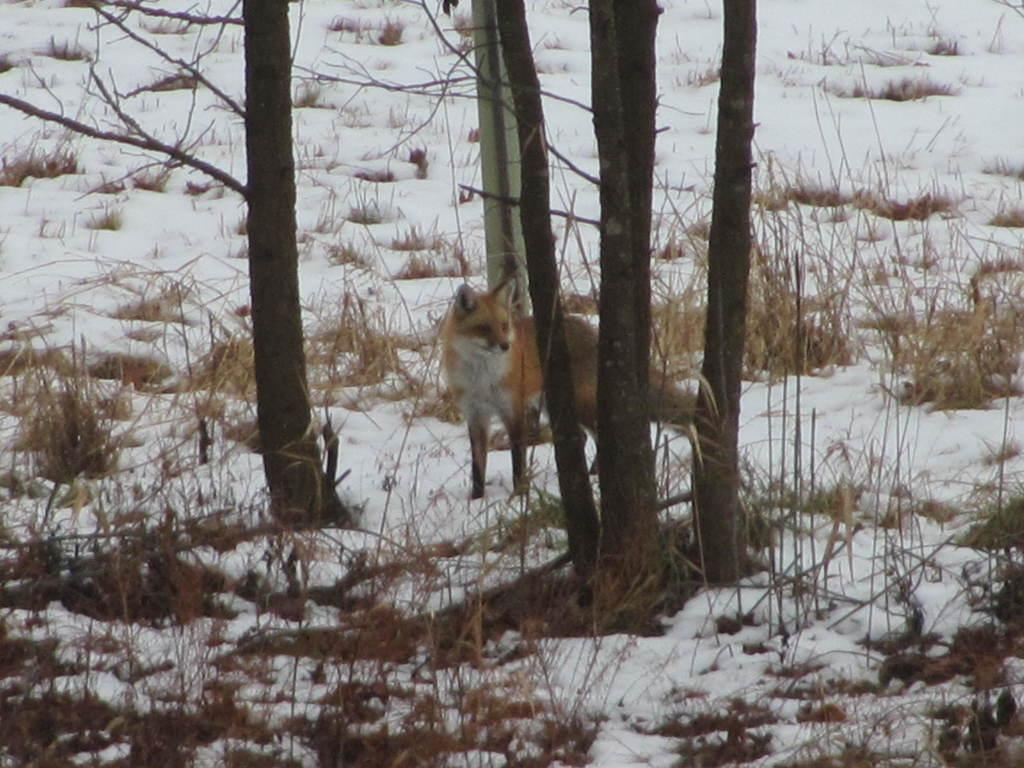What is in the foreground of the image? There are plants and grass in the foreground of the image. What can be seen in the center of the image? There are trees, grass, and a fox in the center of the image. What is the overall setting of the image? The image depicts snow everywhere. Can you see a ghost in the image? No, there is no ghost present in the image. What type of star can be seen in the image? There are no stars visible in the image, as it depicts a snowy landscape with plants, trees, grass, and a fox. 